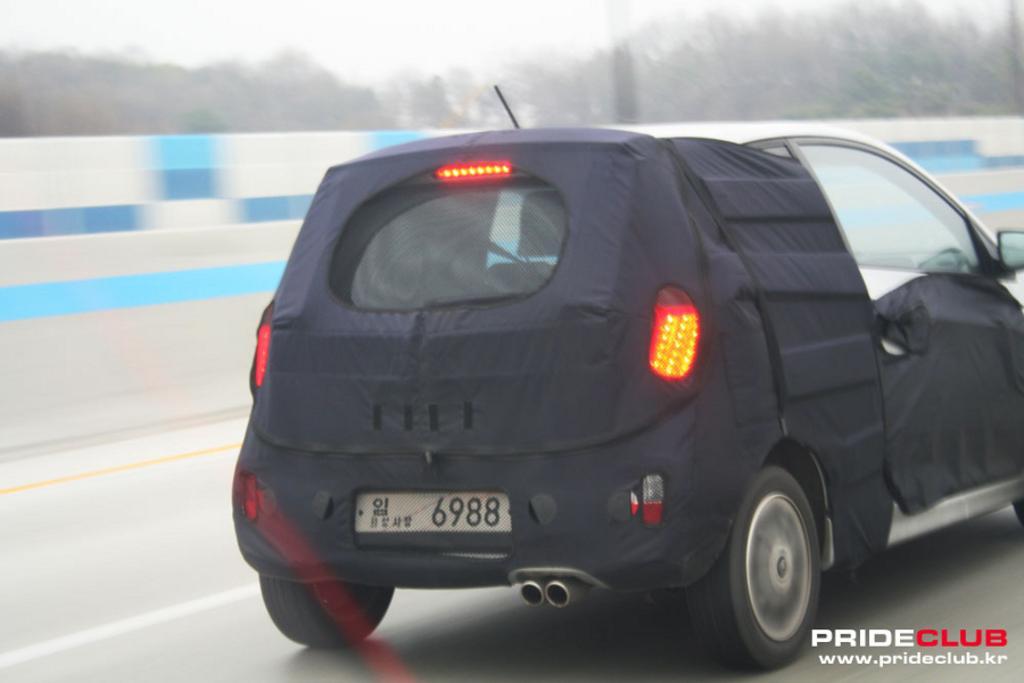Can you describe this image briefly? Here in this picture we can see a black colored car present on the road over there and in the far we can see trees present all over there. 